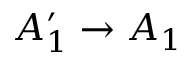Convert formula to latex. <formula><loc_0><loc_0><loc_500><loc_500>A _ { 1 } ^ { \prime } \rightarrow A _ { 1 }</formula> 